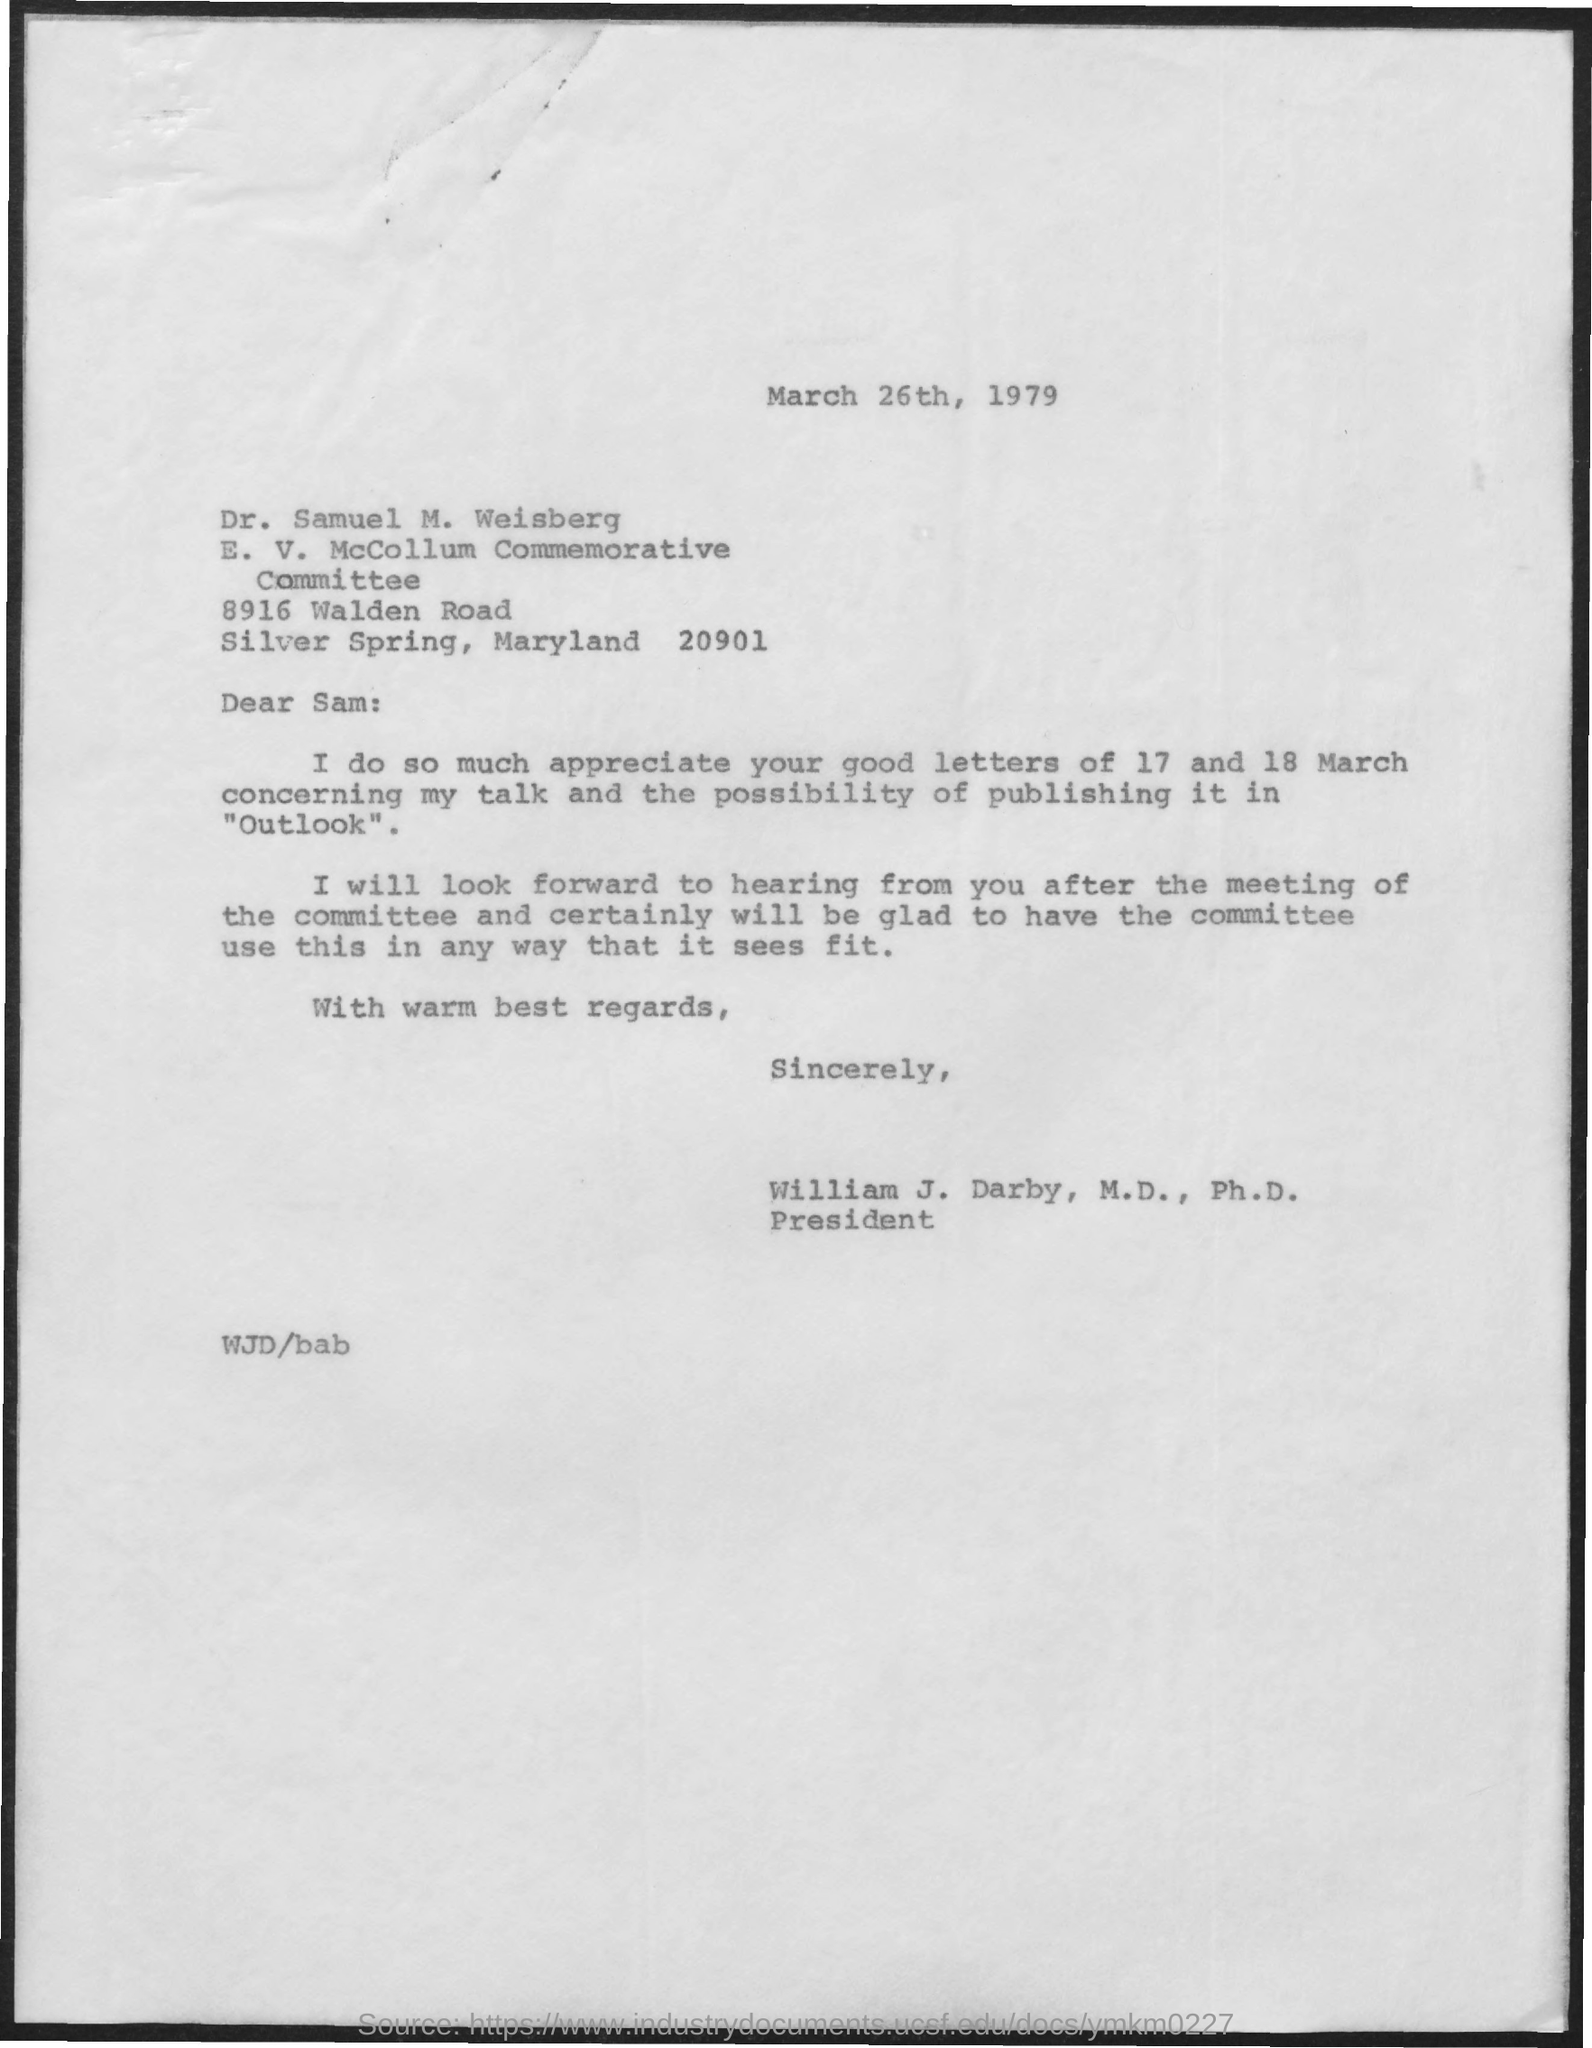Indicate a few pertinent items in this graphic. The letter is addressed to Sam. The sender is William J. Darby, M.D., Ph.D. 